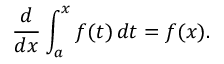Convert formula to latex. <formula><loc_0><loc_0><loc_500><loc_500>{ \frac { d } { d x } } \int _ { a } ^ { x } f ( t ) \, d t = f ( x ) .</formula> 